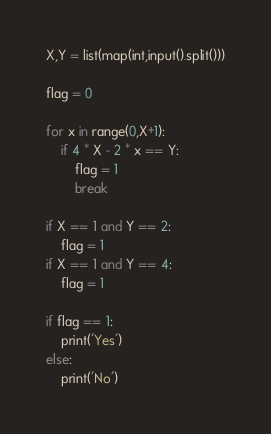<code> <loc_0><loc_0><loc_500><loc_500><_Python_>X,Y = list(map(int,input().split()))

flag = 0

for x in range(0,X+1):
    if 4 * X - 2 * x == Y:
        flag = 1
        break

if X == 1 and Y == 2:
    flag = 1
if X == 1 and Y == 4:
    flag = 1

if flag == 1:
    print('Yes')
else:
    print('No')</code> 